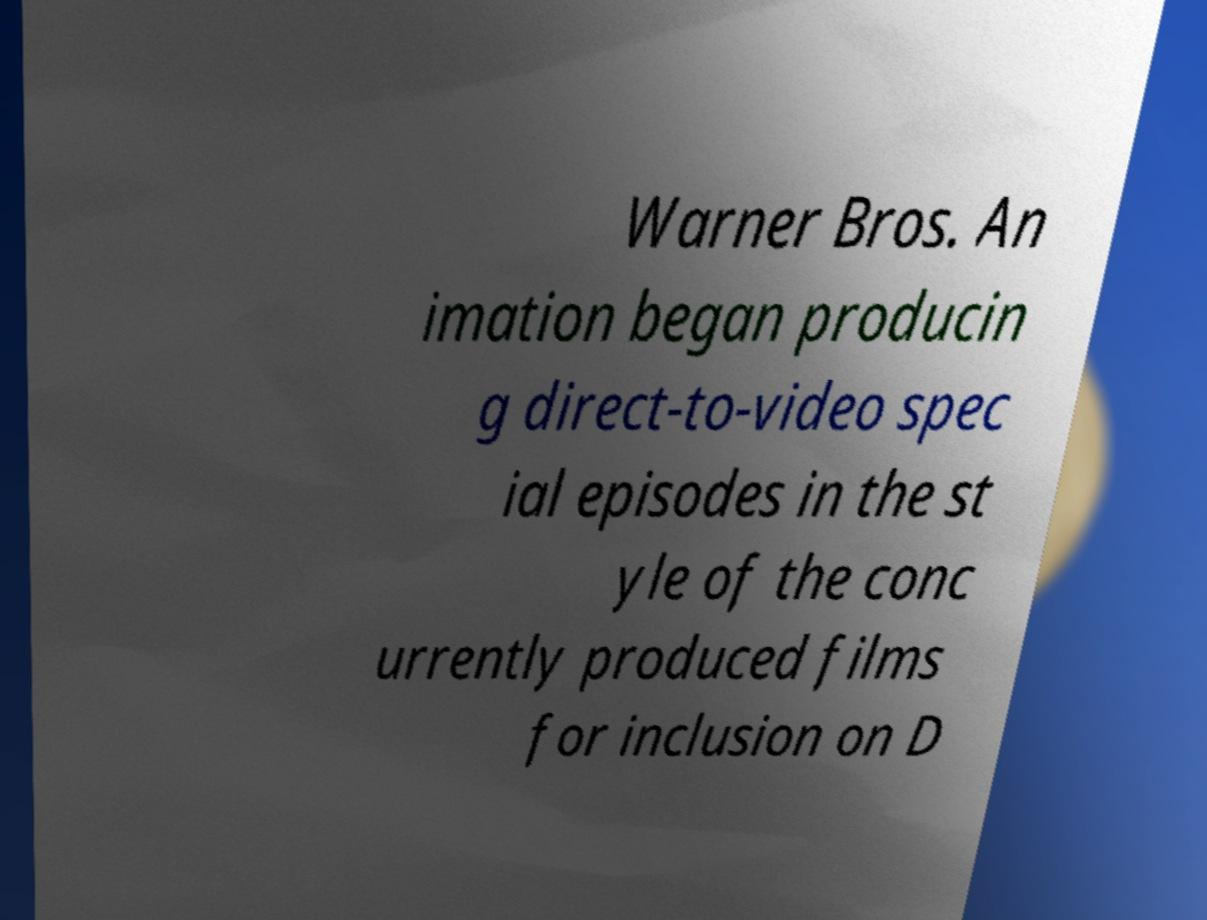I need the written content from this picture converted into text. Can you do that? Warner Bros. An imation began producin g direct-to-video spec ial episodes in the st yle of the conc urrently produced films for inclusion on D 